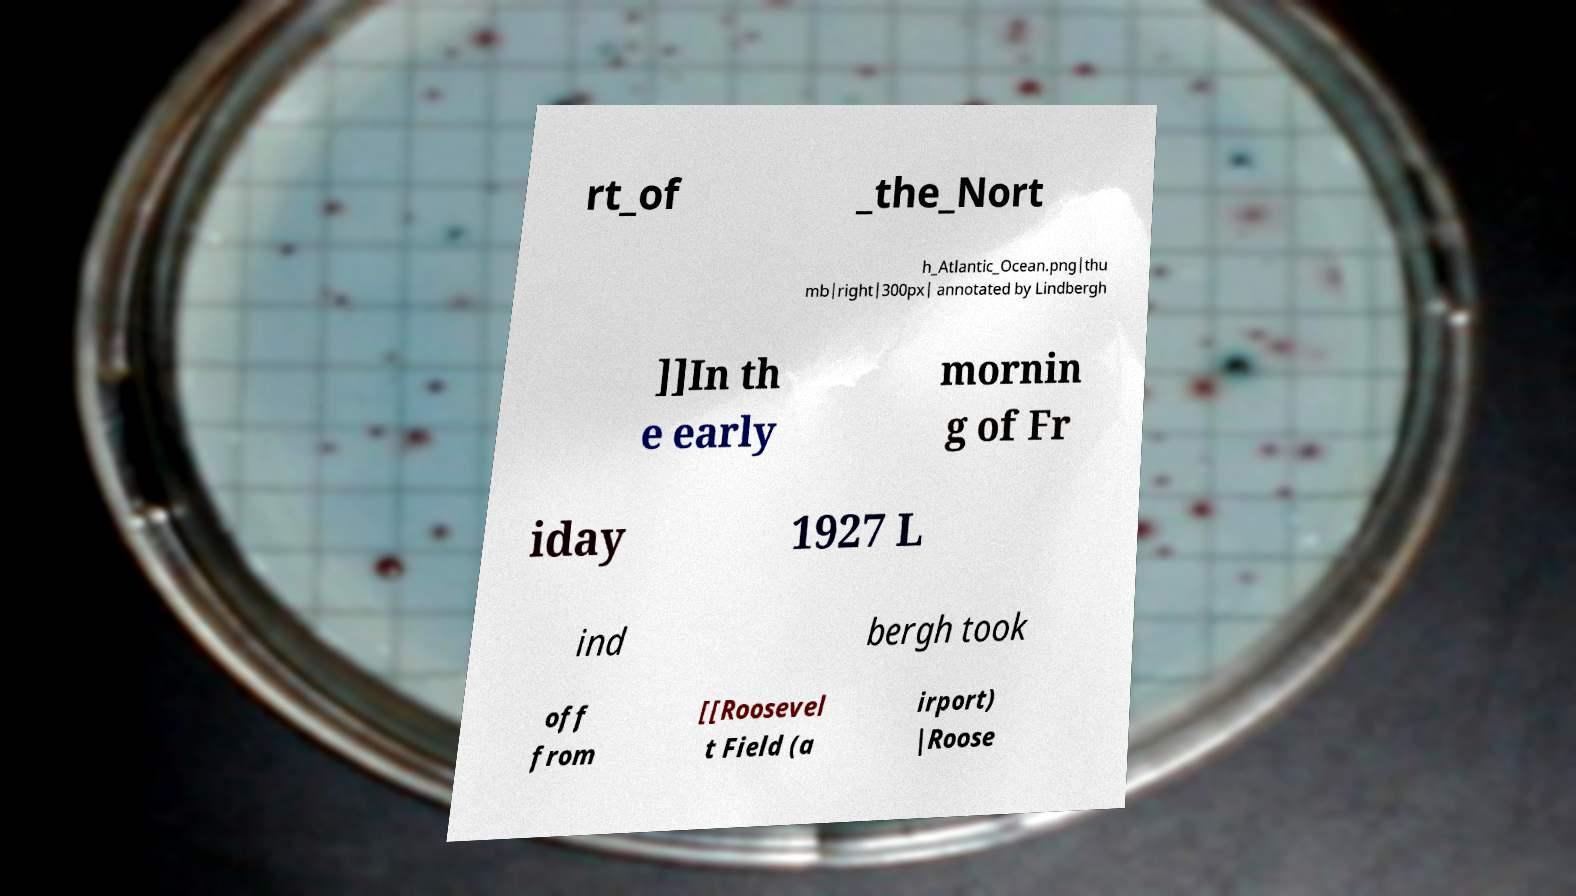Please identify and transcribe the text found in this image. rt_of _the_Nort h_Atlantic_Ocean.png|thu mb|right|300px| annotated by Lindbergh ]]In th e early mornin g of Fr iday 1927 L ind bergh took off from [[Roosevel t Field (a irport) |Roose 